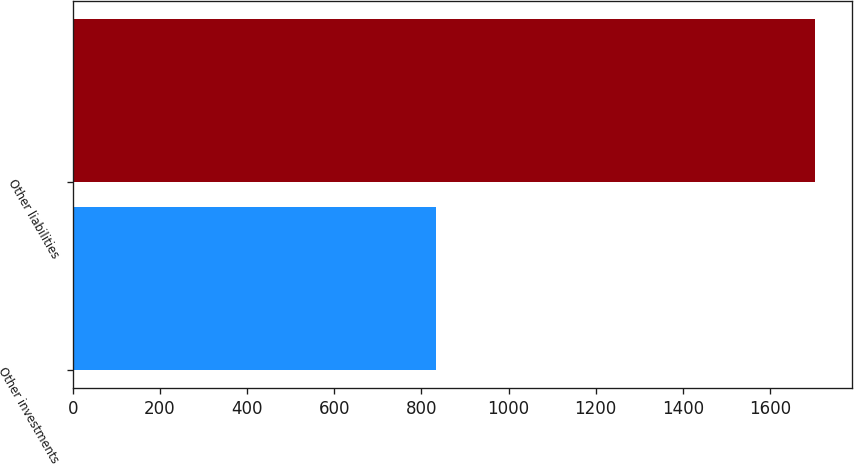Convert chart. <chart><loc_0><loc_0><loc_500><loc_500><bar_chart><fcel>Other investments<fcel>Other liabilities<nl><fcel>834<fcel>1703<nl></chart> 